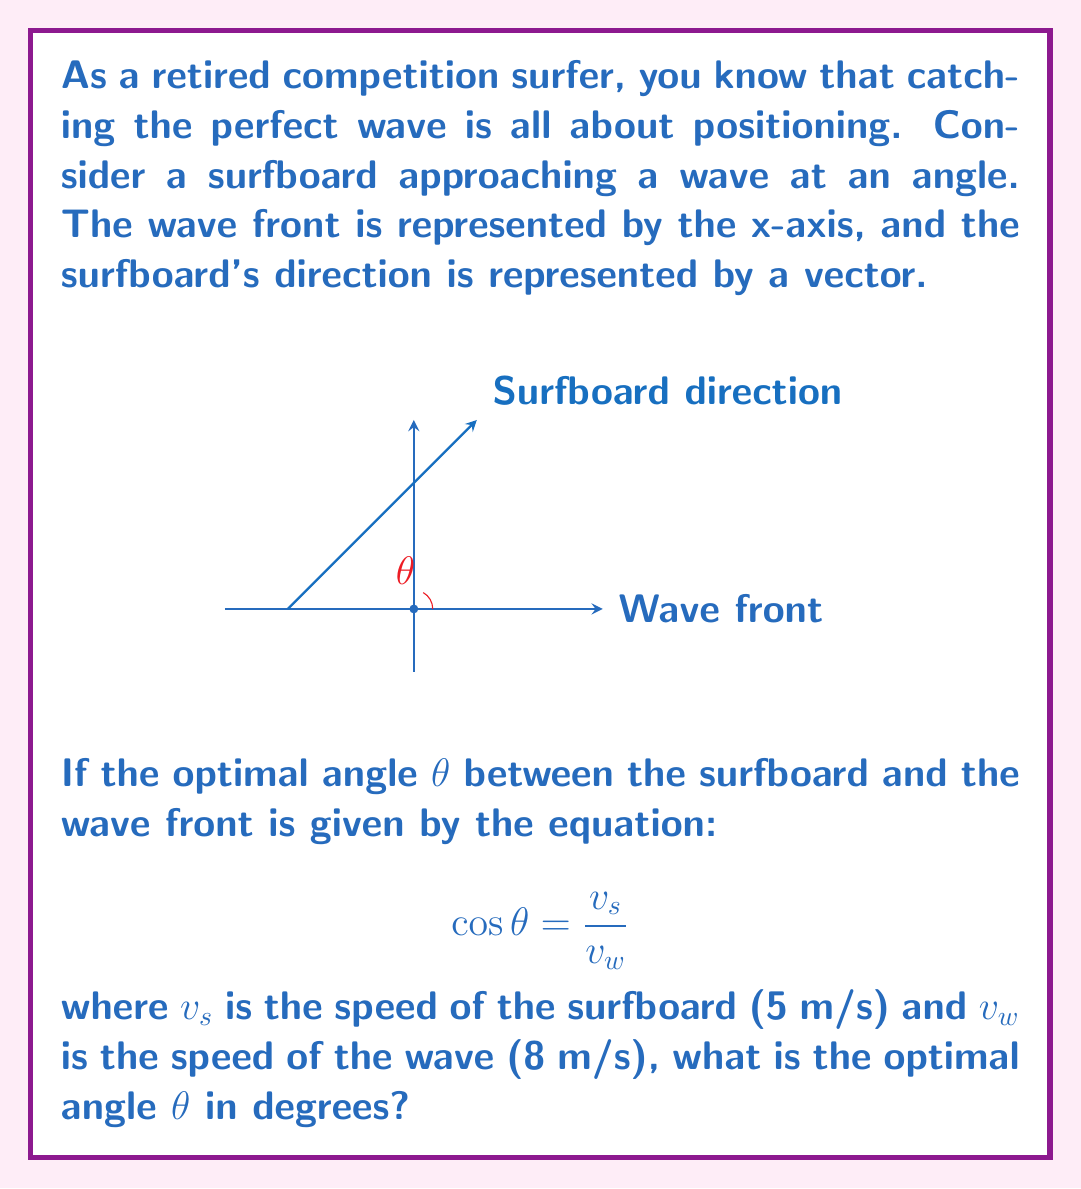Provide a solution to this math problem. Let's approach this step-by-step:

1) We are given the equation:
   $$ \cos θ = \frac{v_s}{v_w} $$

2) We know:
   $v_s = 5$ m/s (speed of surfboard)
   $v_w = 8$ m/s (speed of wave)

3) Let's substitute these values into our equation:
   $$ \cos θ = \frac{5}{8} $$

4) To find θ, we need to take the inverse cosine (arccos) of both sides:
   $$ θ = \arccos(\frac{5}{8}) $$

5) Using a calculator or computational tool, we can evaluate this:
   $$ θ ≈ 0.9273 \text{ radians} $$

6) The question asks for the angle in degrees. To convert from radians to degrees, we multiply by $\frac{180°}{\pi}$:
   $$ θ ≈ 0.9273 \times \frac{180°}{\pi} ≈ 53.13° $$

7) Rounding to the nearest whole degree:
   $$ θ ≈ 53° $$

This angle represents the optimal approach for the surfboard to catch the wave, balancing the speed of the board with the speed of the wave.
Answer: 53° 